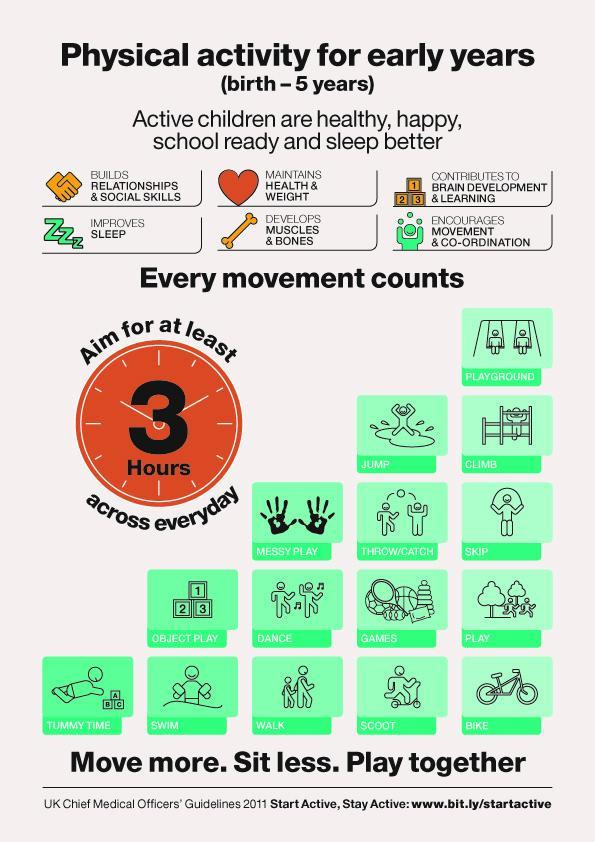How many children are dancing in this infographic?
Answer the question with a short phrase. 2 How many children are walking in this infographic? 2 How many children are swimming in this infographic? 1 